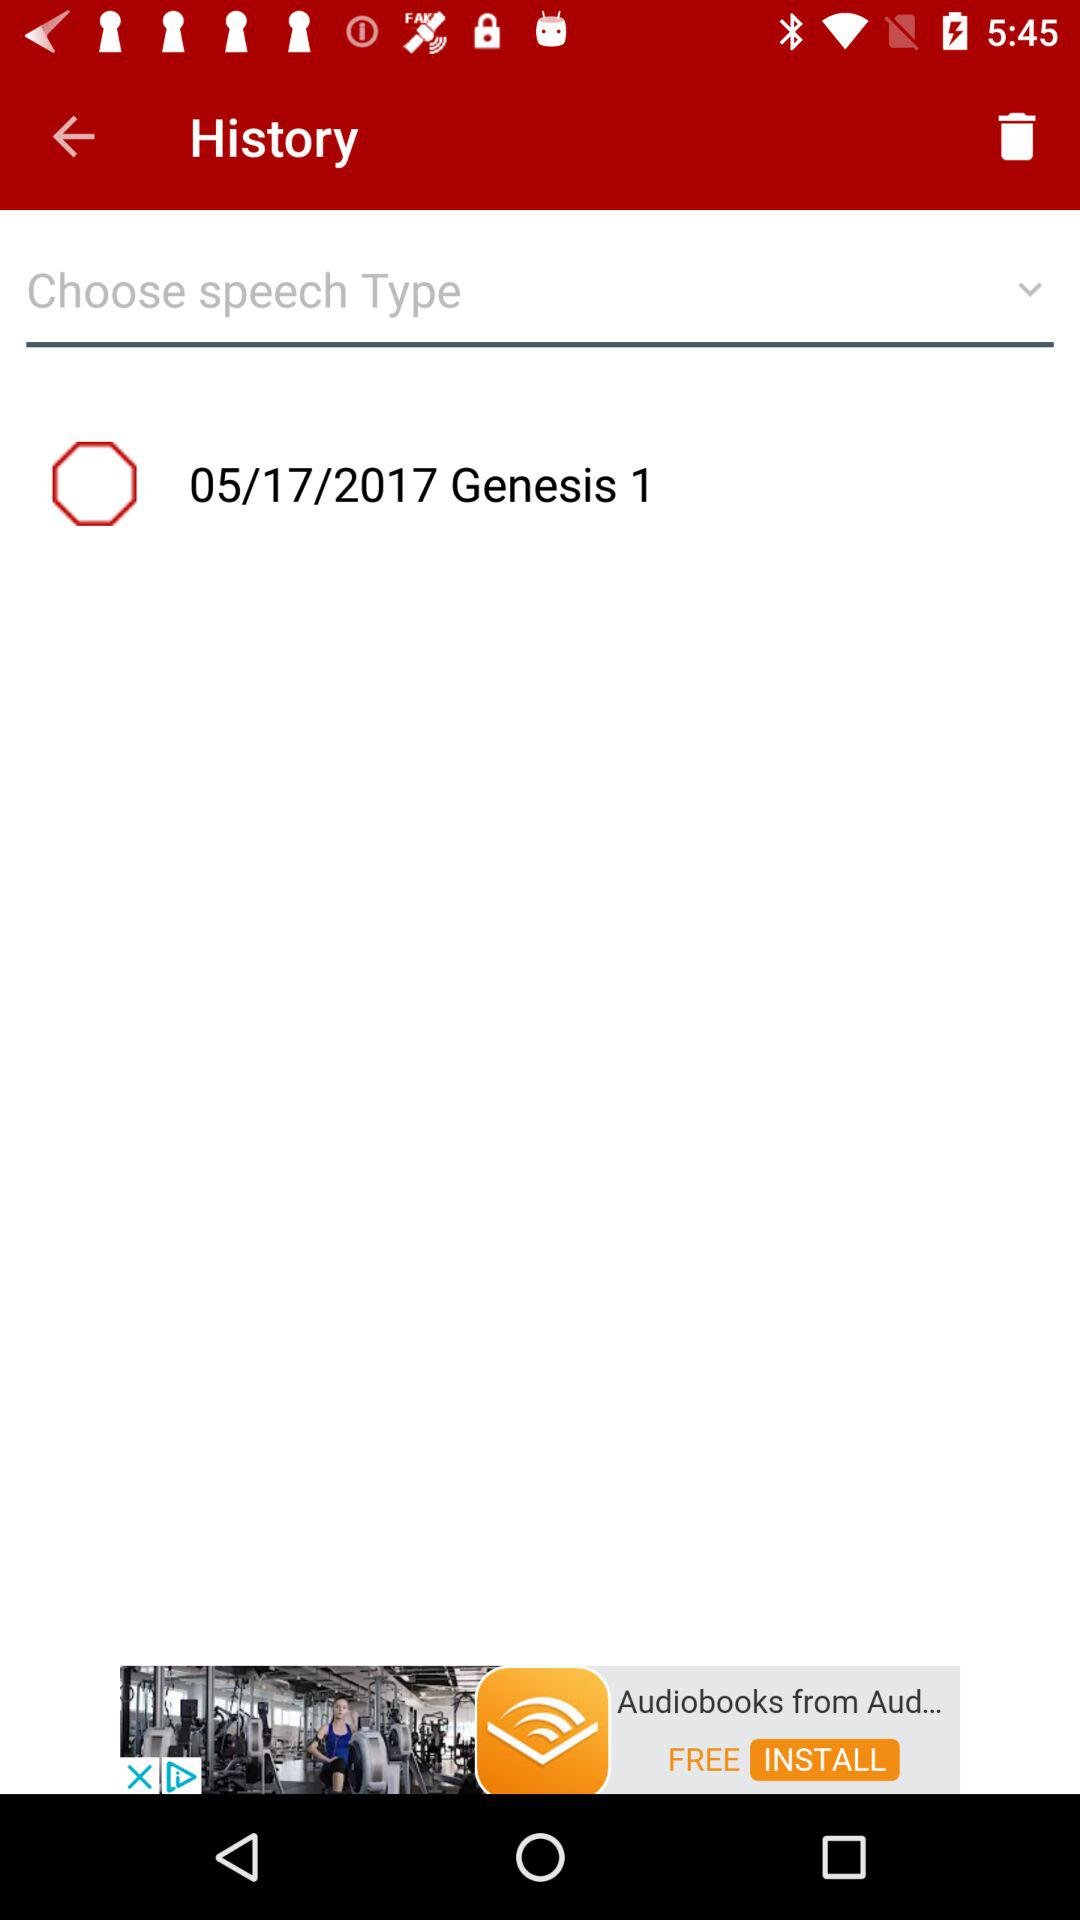What is the date of Genesis 1? The date is May 17, 2017. 